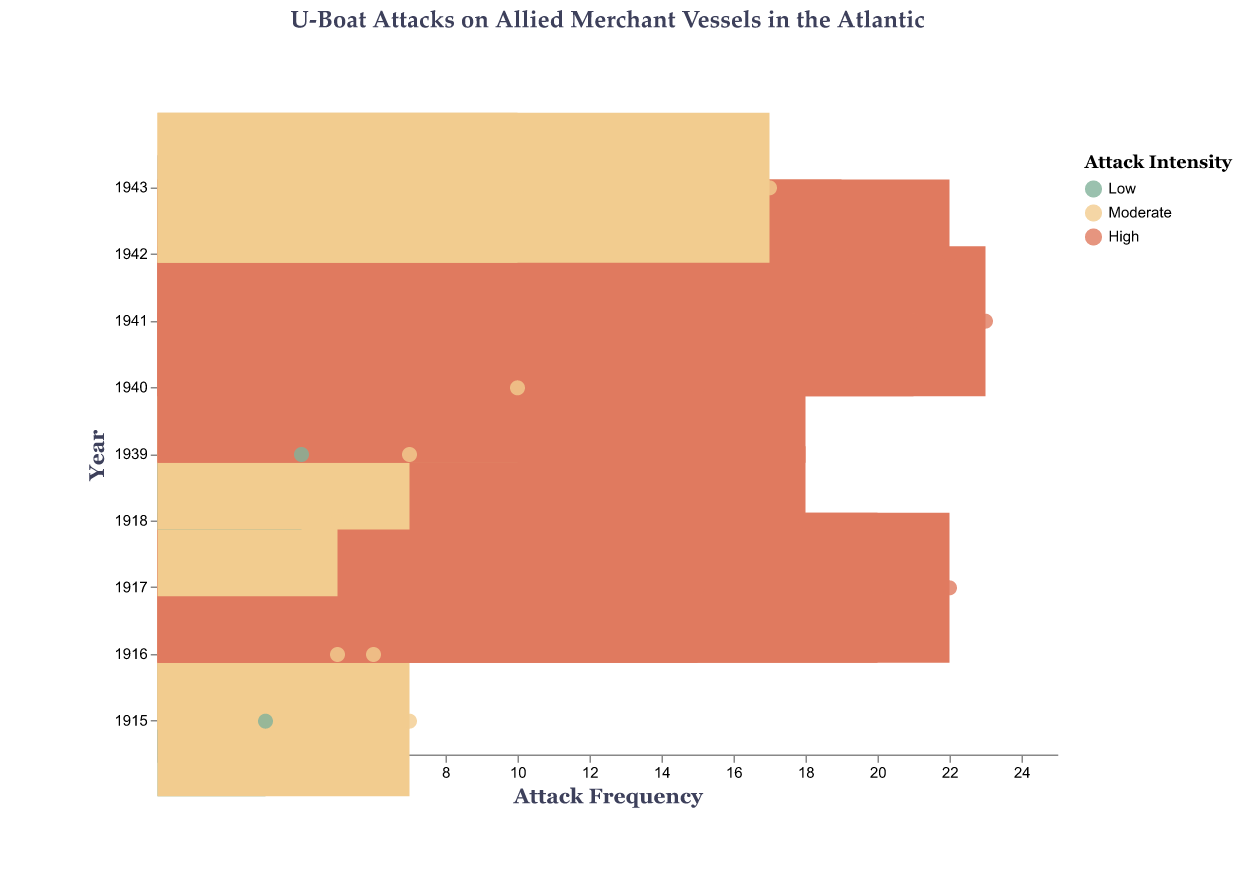What is the title of the figure? Look at the text at the top of the figure. The title is "U-Boat Attacks on Allied Merchant Vessels in the Atlantic".
Answer: U-Boat Attacks on Allied Merchant Vessels in the Atlantic What does the color of the dots represent in this plot? Refer to the legend on the right side of the plot where it explains that the color represents the intensity of the attacks: Low, Moderate, and High.
Answer: Intensity of attacks Which year had the highest frequency of attacks? Observe the x-axis for frequencies and find the highest value, then look at the corresponding year on the y-axis. The year with the highest frequency (23) is 1941.
Answer: 1941 How did the attack frequency change from 1915 to 1917? Look at the year 1915 and 1917, comparing the frequency values. In 1915, the frequencies were 3 and 7. In 1917, the frequencies were 15, 20, and 22. Thus, there was a significant increase from 1915 to 1917.
Answer: Increased significantly In which months of 1917 did U-Boat attacks reach high intensity? Find the dots for the year 1917, and check the months of the dots which have the color representing high intensity. The months are March, April, and May.
Answer: March, April, May What is the average frequency of attacks in 1940? Identify the frequency values for 1940: 10 (March), 15 (June), and 18 (September). Sum these values (10 + 15 + 18 = 43) and then divide by the number of values (43 / 3).
Answer: 14.33 Compare the attack frequencies for April and July of 1918. Which month had higher intensity? Note the frequency and intensity for April and July of 1918. April has no data, but in July, the frequency is 18 with high intensity. Thus, July had higher intensity attack.
Answer: July How many data points represent moderate intensity attacks in the entire plot? Count the number of dots colored for moderate intensity. The moderate intensity dots are in 1915 (June), 1916 (April, January), 1918 (November), 1939 (December), 1940 (March), 1943 (April, November). There are 8 dots in total.
Answer: 8 What is the trend in attack intensity over the years shown in the plot? Observe the color of dots from the earliest year (1915) to the latest year (1943), noting any patterns. Attack intensity generally shifts from low/moderate during early years to high during mid-periods (1917-1942), then it becomes moderate again in 1943.
Answer: Shifts from low/moderate to high, then moderate again 